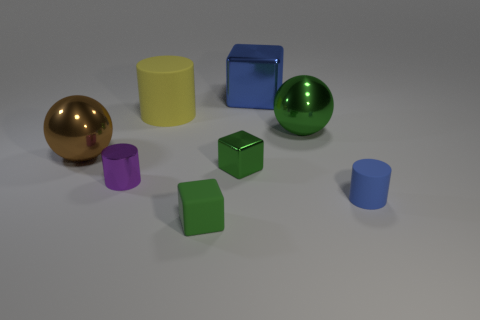How many things are both on the left side of the large green shiny object and to the right of the big brown metallic ball?
Keep it short and to the point. 5. How many blue things are metal blocks or matte blocks?
Offer a very short reply. 1. What number of metallic objects are either large brown balls or big things?
Ensure brevity in your answer.  3. Are there any big brown spheres?
Make the answer very short. Yes. Do the small purple object and the large brown metallic thing have the same shape?
Your response must be concise. No. How many large objects are left of the rubber thing that is behind the blue object that is in front of the purple thing?
Keep it short and to the point. 1. There is a green thing that is behind the blue matte object and in front of the green shiny ball; what is its material?
Offer a very short reply. Metal. There is a rubber object that is both to the right of the big yellow rubber object and on the left side of the small matte cylinder; what is its color?
Your response must be concise. Green. Is there any other thing that has the same color as the big rubber object?
Offer a terse response. No. What shape is the tiny object that is right of the green cube that is on the right side of the cube that is in front of the tiny rubber cylinder?
Your answer should be very brief. Cylinder. 